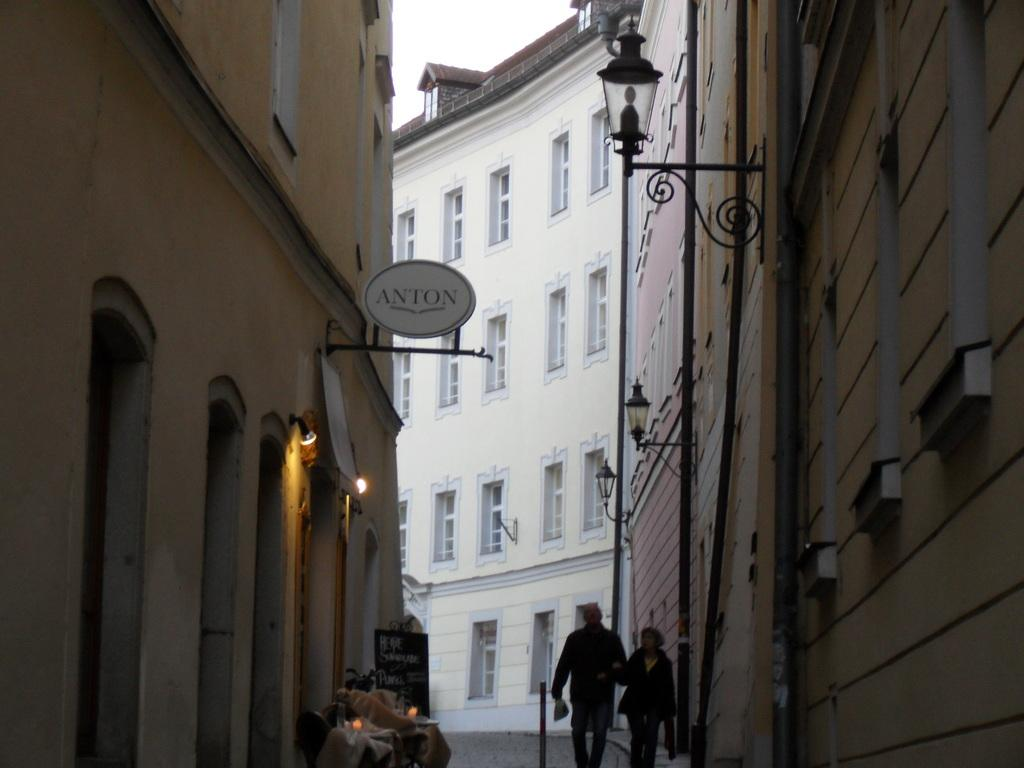What type of structures can be seen in the image? There are buildings in the image. What are the two persons in the image doing? Two persons are walking in the street. What is the title of the book the person is holding in the image? There is no book or person holding a book present in the image. How many passengers are visible in the image? There are no passengers visible in the image, as it only features two persons walking in the street. 